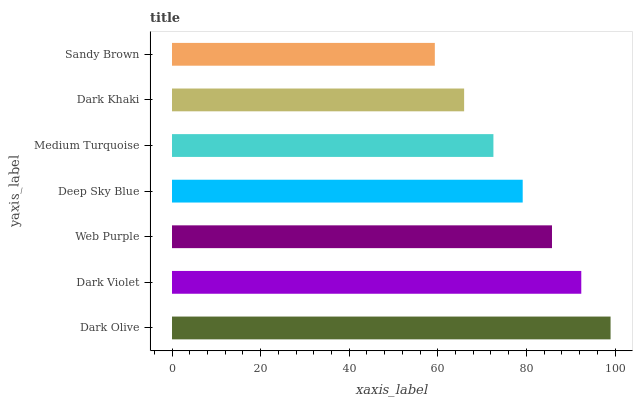Is Sandy Brown the minimum?
Answer yes or no. Yes. Is Dark Olive the maximum?
Answer yes or no. Yes. Is Dark Violet the minimum?
Answer yes or no. No. Is Dark Violet the maximum?
Answer yes or no. No. Is Dark Olive greater than Dark Violet?
Answer yes or no. Yes. Is Dark Violet less than Dark Olive?
Answer yes or no. Yes. Is Dark Violet greater than Dark Olive?
Answer yes or no. No. Is Dark Olive less than Dark Violet?
Answer yes or no. No. Is Deep Sky Blue the high median?
Answer yes or no. Yes. Is Deep Sky Blue the low median?
Answer yes or no. Yes. Is Dark Khaki the high median?
Answer yes or no. No. Is Sandy Brown the low median?
Answer yes or no. No. 